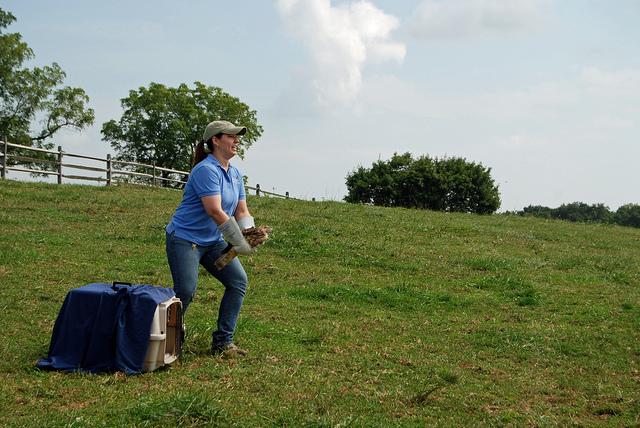Would this be a good locale for cattle to roam in?
Short answer required. Yes. What is this man holding?
Keep it brief. Bird. What are they throwing?
Give a very brief answer. Bird. What is the woman wearing?
Give a very brief answer. Gloves. Is the girl wearing cowboy boots?
Write a very short answer. No. What trick is being shown in this scene?
Keep it brief. Bird flight. What is the woman looking at?
Short answer required. Sky. What is in the box?
Short answer required. Nothing. Is the man wearing shorts?
Concise answer only. No. Which type of cloud is the most visible in the sky?
Concise answer only. White. What pattern is on the man's shirt?
Write a very short answer. None. Is she wearing a hat?
Short answer required. Yes. What does the girl have on her head?
Quick response, please. Hat. What color is the ladies hair?
Give a very brief answer. Brown. What is over the woman's head?
Answer briefly. Hat. 